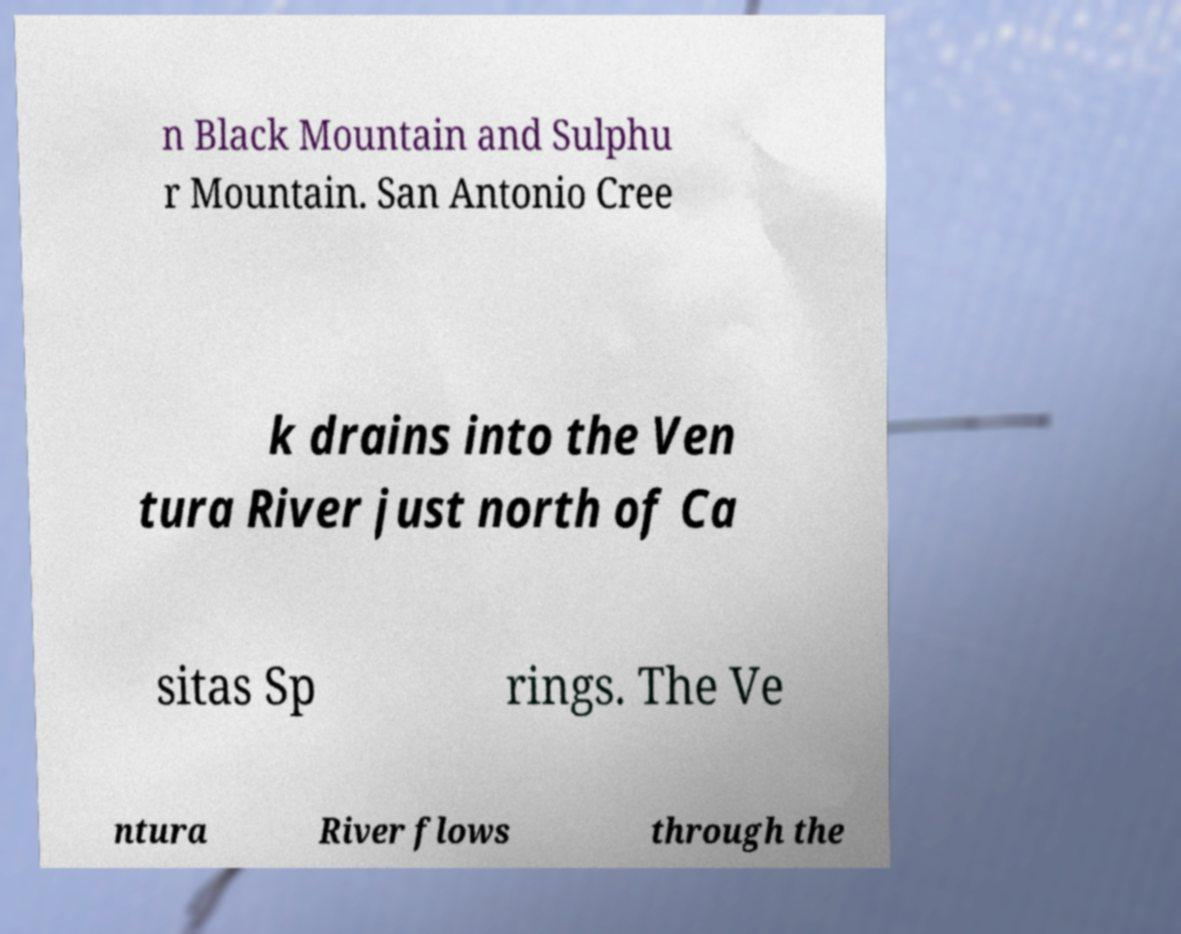I need the written content from this picture converted into text. Can you do that? n Black Mountain and Sulphu r Mountain. San Antonio Cree k drains into the Ven tura River just north of Ca sitas Sp rings. The Ve ntura River flows through the 